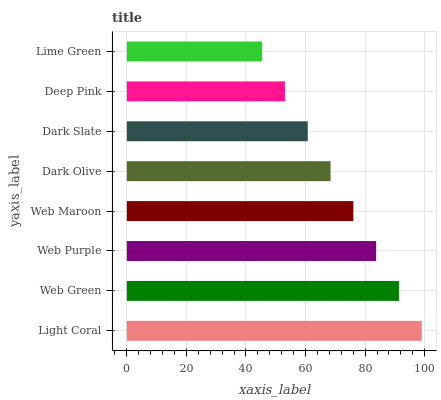Is Lime Green the minimum?
Answer yes or no. Yes. Is Light Coral the maximum?
Answer yes or no. Yes. Is Web Green the minimum?
Answer yes or no. No. Is Web Green the maximum?
Answer yes or no. No. Is Light Coral greater than Web Green?
Answer yes or no. Yes. Is Web Green less than Light Coral?
Answer yes or no. Yes. Is Web Green greater than Light Coral?
Answer yes or no. No. Is Light Coral less than Web Green?
Answer yes or no. No. Is Web Maroon the high median?
Answer yes or no. Yes. Is Dark Olive the low median?
Answer yes or no. Yes. Is Lime Green the high median?
Answer yes or no. No. Is Lime Green the low median?
Answer yes or no. No. 